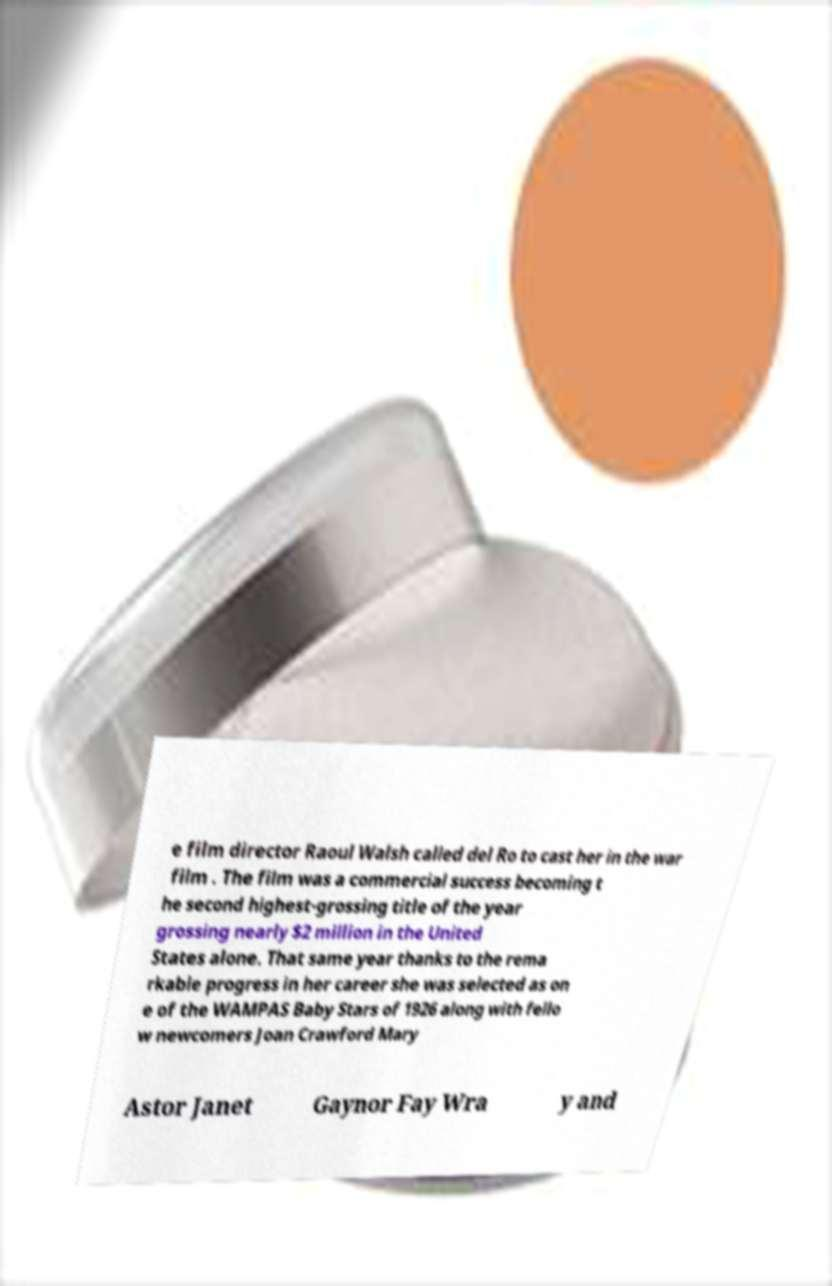Can you read and provide the text displayed in the image?This photo seems to have some interesting text. Can you extract and type it out for me? e film director Raoul Walsh called del Ro to cast her in the war film . The film was a commercial success becoming t he second highest-grossing title of the year grossing nearly $2 million in the United States alone. That same year thanks to the rema rkable progress in her career she was selected as on e of the WAMPAS Baby Stars of 1926 along with fello w newcomers Joan Crawford Mary Astor Janet Gaynor Fay Wra y and 